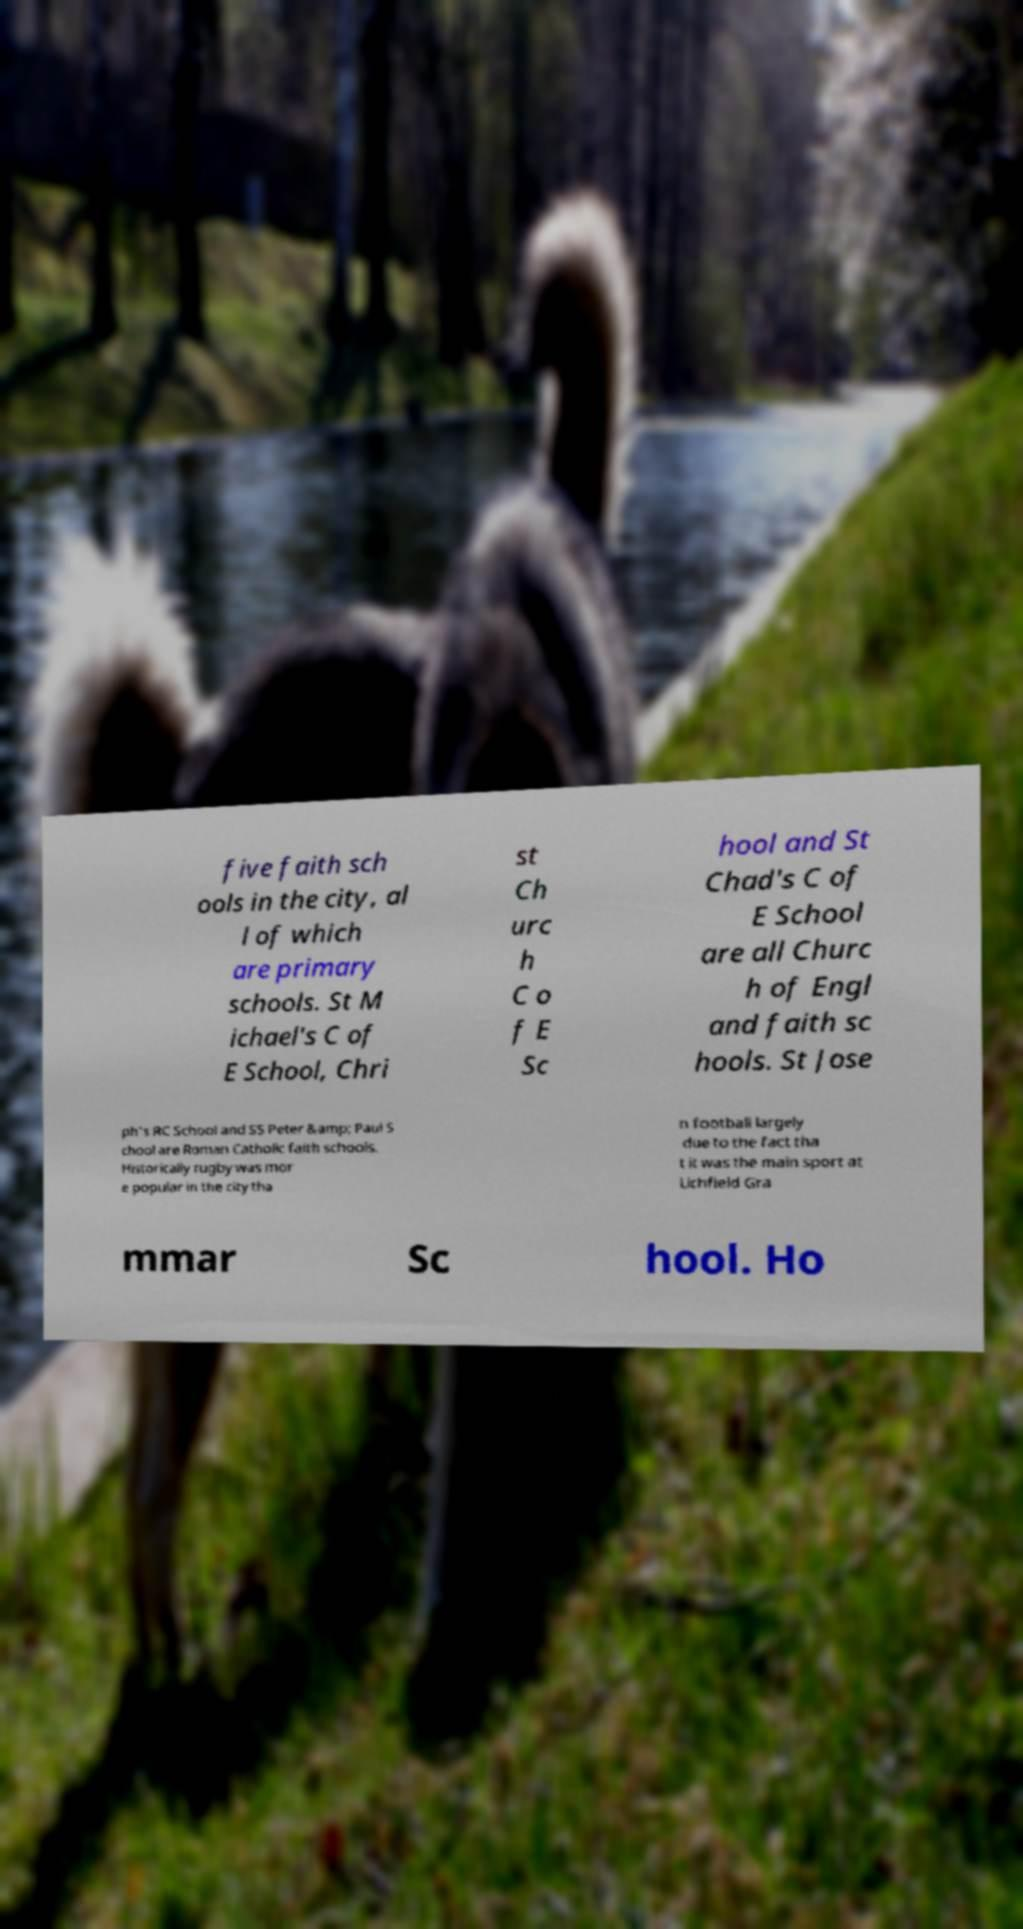Can you read and provide the text displayed in the image?This photo seems to have some interesting text. Can you extract and type it out for me? five faith sch ools in the city, al l of which are primary schools. St M ichael's C of E School, Chri st Ch urc h C o f E Sc hool and St Chad's C of E School are all Churc h of Engl and faith sc hools. St Jose ph's RC School and SS Peter &amp; Paul S chool are Roman Catholic faith schools. Historically rugby was mor e popular in the city tha n football largely due to the fact tha t it was the main sport at Lichfield Gra mmar Sc hool. Ho 